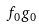<formula> <loc_0><loc_0><loc_500><loc_500>f _ { 0 } g _ { 0 }</formula> 